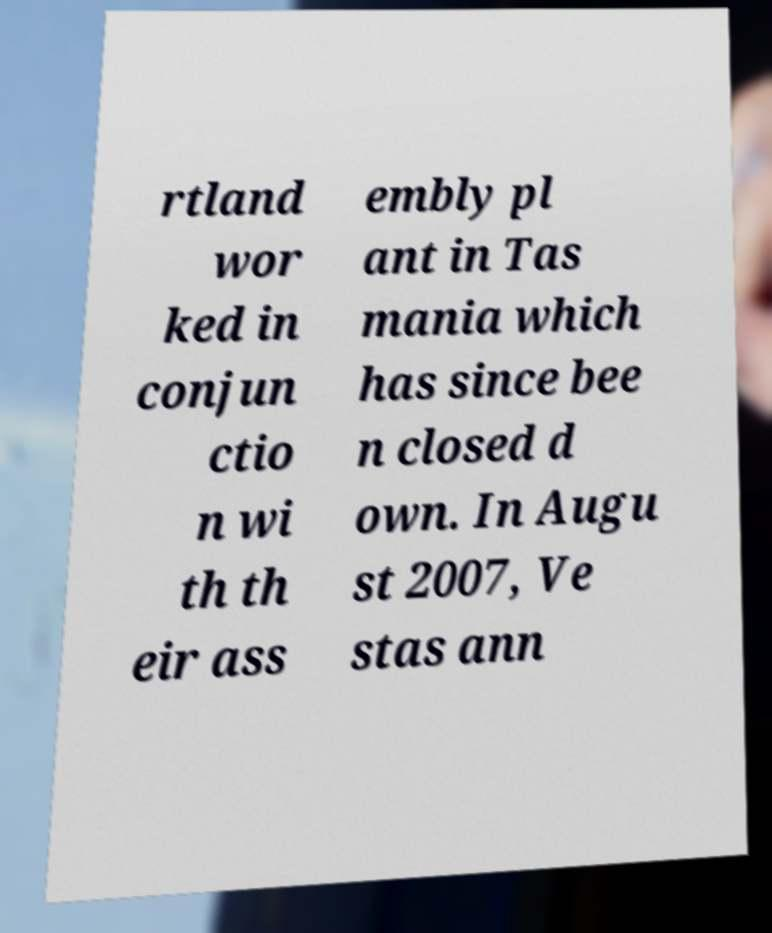What messages or text are displayed in this image? I need them in a readable, typed format. rtland wor ked in conjun ctio n wi th th eir ass embly pl ant in Tas mania which has since bee n closed d own. In Augu st 2007, Ve stas ann 